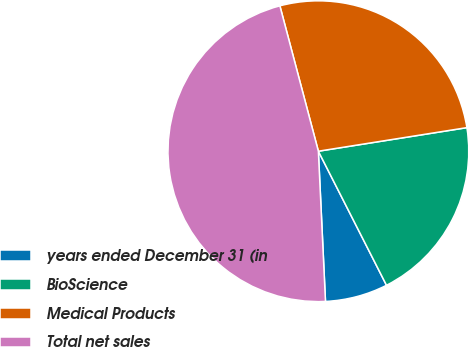Convert chart to OTSL. <chart><loc_0><loc_0><loc_500><loc_500><pie_chart><fcel>years ended December 31 (in<fcel>BioScience<fcel>Medical Products<fcel>Total net sales<nl><fcel>6.73%<fcel>20.02%<fcel>26.61%<fcel>46.63%<nl></chart> 